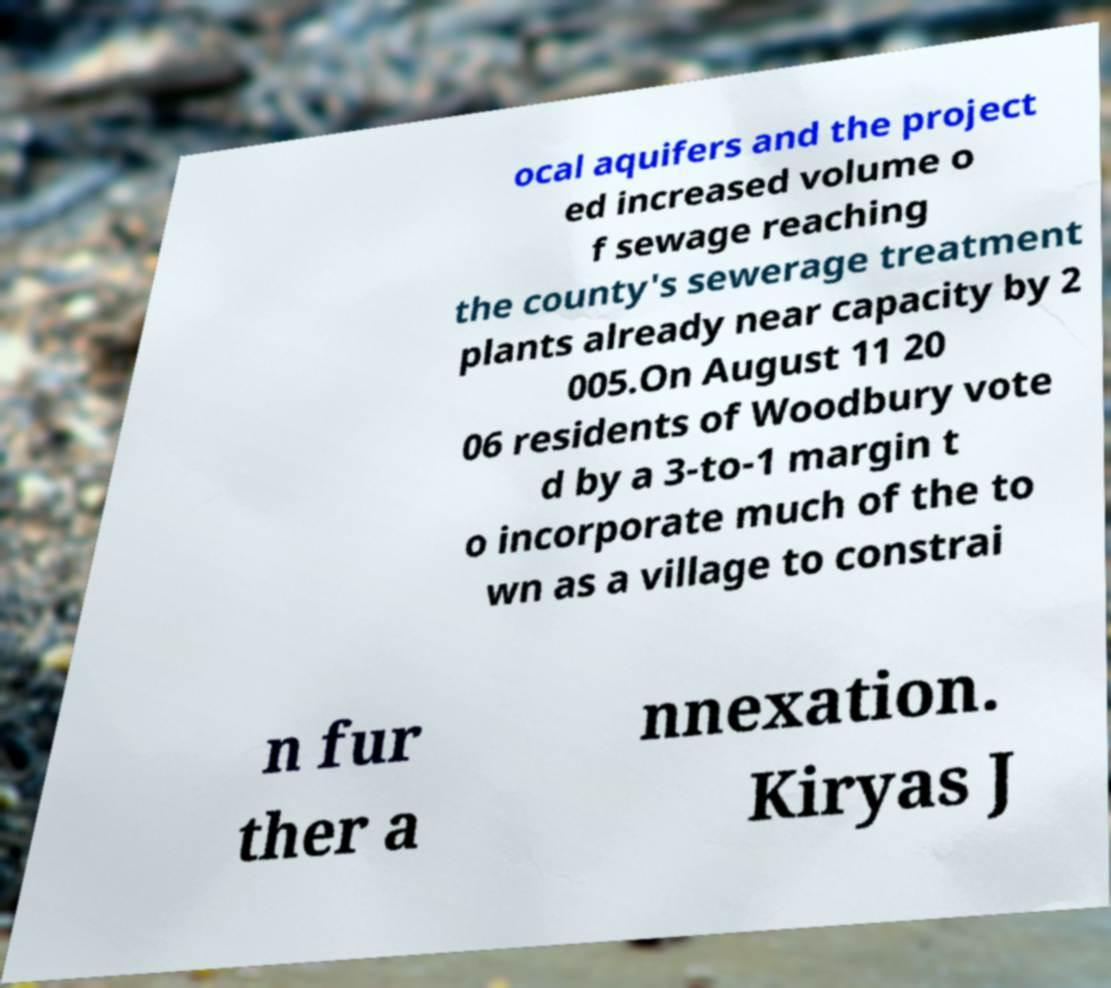For documentation purposes, I need the text within this image transcribed. Could you provide that? ocal aquifers and the project ed increased volume o f sewage reaching the county's sewerage treatment plants already near capacity by 2 005.On August 11 20 06 residents of Woodbury vote d by a 3-to-1 margin t o incorporate much of the to wn as a village to constrai n fur ther a nnexation. Kiryas J 